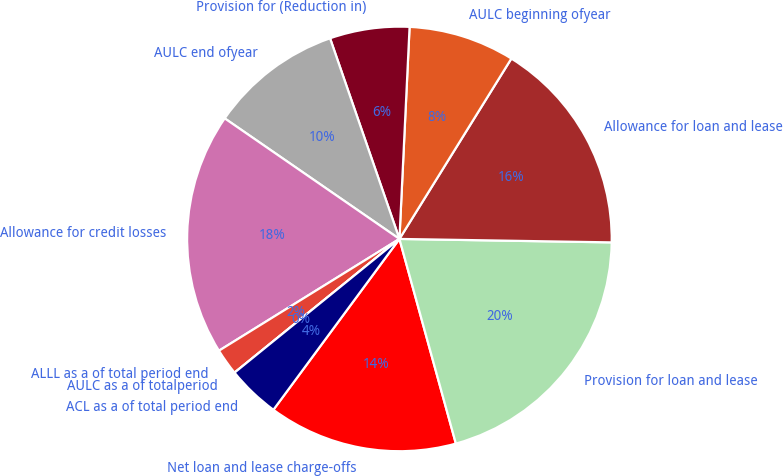Convert chart to OTSL. <chart><loc_0><loc_0><loc_500><loc_500><pie_chart><fcel>Net loan and lease charge-offs<fcel>Provision for loan and lease<fcel>Allowance for loan and lease<fcel>AULC beginning ofyear<fcel>Provision for (Reduction in)<fcel>AULC end ofyear<fcel>Allowance for credit losses<fcel>ALLL as a of total period end<fcel>AULC as a of totalperiod<fcel>ACL as a of total period end<nl><fcel>14.4%<fcel>20.46%<fcel>16.42%<fcel>8.08%<fcel>6.06%<fcel>10.09%<fcel>18.44%<fcel>2.02%<fcel>0.0%<fcel>4.04%<nl></chart> 